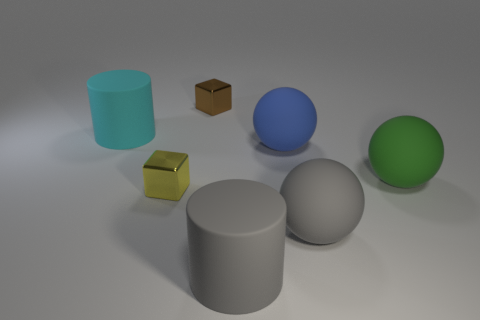There is a gray object that is behind the gray matte cylinder; how many small yellow metallic objects are left of it?
Your answer should be compact. 1. What number of objects are either large gray objects or small things behind the small yellow metal thing?
Provide a succinct answer. 3. Is there a big green thing that has the same material as the large blue ball?
Your answer should be compact. Yes. What number of things are both behind the big cyan matte cylinder and on the right side of the large blue matte thing?
Your answer should be compact. 0. There is a cylinder behind the big gray ball; what is its material?
Offer a very short reply. Rubber. There is a gray ball that is made of the same material as the green object; what is its size?
Your response must be concise. Large. There is a large gray ball; are there any large green things left of it?
Offer a very short reply. No. The blue matte thing that is the same shape as the large green rubber thing is what size?
Offer a very short reply. Large. Is the number of blue spheres less than the number of blue cubes?
Provide a short and direct response. No. How many big matte objects are there?
Offer a terse response. 5. 